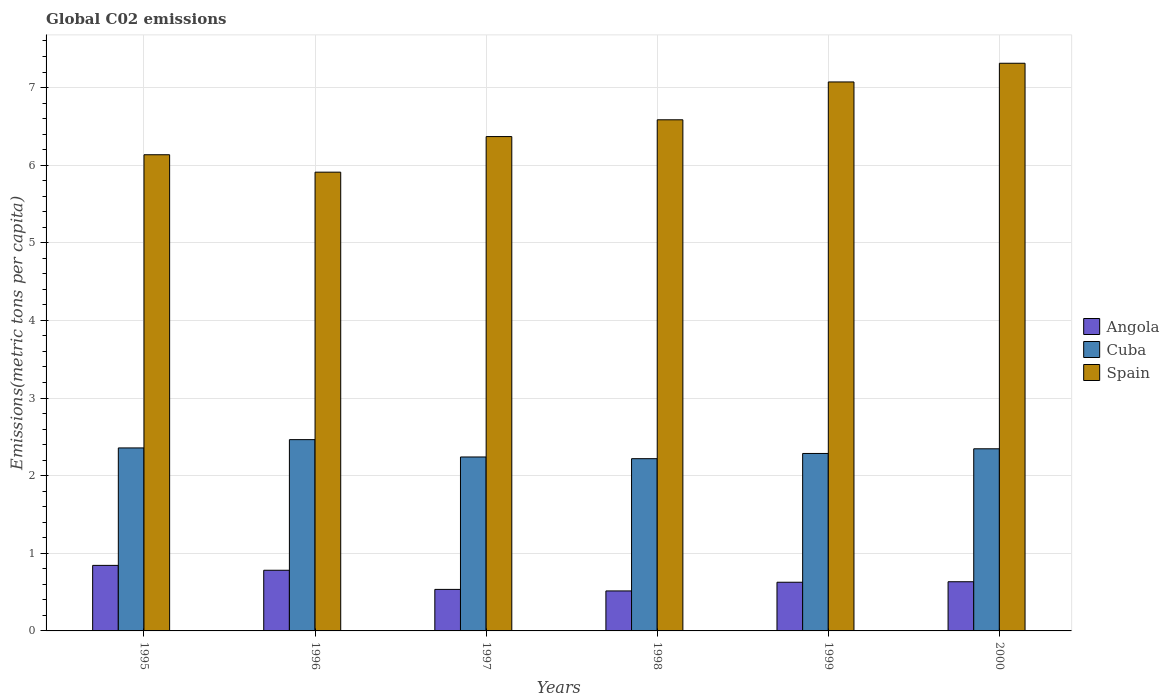How many different coloured bars are there?
Ensure brevity in your answer.  3. How many groups of bars are there?
Your response must be concise. 6. Are the number of bars per tick equal to the number of legend labels?
Your answer should be very brief. Yes. How many bars are there on the 4th tick from the left?
Ensure brevity in your answer.  3. How many bars are there on the 3rd tick from the right?
Provide a short and direct response. 3. What is the amount of CO2 emitted in in Spain in 1998?
Offer a very short reply. 6.58. Across all years, what is the maximum amount of CO2 emitted in in Angola?
Offer a terse response. 0.84. Across all years, what is the minimum amount of CO2 emitted in in Angola?
Your answer should be very brief. 0.52. In which year was the amount of CO2 emitted in in Cuba maximum?
Keep it short and to the point. 1996. In which year was the amount of CO2 emitted in in Angola minimum?
Make the answer very short. 1998. What is the total amount of CO2 emitted in in Cuba in the graph?
Ensure brevity in your answer.  13.91. What is the difference between the amount of CO2 emitted in in Spain in 1997 and that in 1998?
Make the answer very short. -0.22. What is the difference between the amount of CO2 emitted in in Cuba in 1996 and the amount of CO2 emitted in in Angola in 1999?
Keep it short and to the point. 1.84. What is the average amount of CO2 emitted in in Angola per year?
Ensure brevity in your answer.  0.66. In the year 1997, what is the difference between the amount of CO2 emitted in in Spain and amount of CO2 emitted in in Angola?
Offer a very short reply. 5.83. What is the ratio of the amount of CO2 emitted in in Spain in 1995 to that in 1996?
Your answer should be compact. 1.04. Is the amount of CO2 emitted in in Spain in 1997 less than that in 2000?
Provide a short and direct response. Yes. What is the difference between the highest and the second highest amount of CO2 emitted in in Angola?
Your answer should be very brief. 0.06. What is the difference between the highest and the lowest amount of CO2 emitted in in Spain?
Make the answer very short. 1.4. In how many years, is the amount of CO2 emitted in in Angola greater than the average amount of CO2 emitted in in Angola taken over all years?
Offer a terse response. 2. Is the sum of the amount of CO2 emitted in in Spain in 1995 and 1999 greater than the maximum amount of CO2 emitted in in Cuba across all years?
Give a very brief answer. Yes. What does the 1st bar from the right in 1998 represents?
Ensure brevity in your answer.  Spain. Is it the case that in every year, the sum of the amount of CO2 emitted in in Spain and amount of CO2 emitted in in Angola is greater than the amount of CO2 emitted in in Cuba?
Offer a terse response. Yes. Are all the bars in the graph horizontal?
Offer a terse response. No. What is the difference between two consecutive major ticks on the Y-axis?
Offer a terse response. 1. Are the values on the major ticks of Y-axis written in scientific E-notation?
Make the answer very short. No. Does the graph contain any zero values?
Your response must be concise. No. How many legend labels are there?
Keep it short and to the point. 3. What is the title of the graph?
Make the answer very short. Global C02 emissions. Does "Montenegro" appear as one of the legend labels in the graph?
Your answer should be very brief. No. What is the label or title of the X-axis?
Your answer should be compact. Years. What is the label or title of the Y-axis?
Offer a very short reply. Emissions(metric tons per capita). What is the Emissions(metric tons per capita) in Angola in 1995?
Ensure brevity in your answer.  0.84. What is the Emissions(metric tons per capita) of Cuba in 1995?
Give a very brief answer. 2.36. What is the Emissions(metric tons per capita) in Spain in 1995?
Make the answer very short. 6.13. What is the Emissions(metric tons per capita) of Angola in 1996?
Your answer should be compact. 0.78. What is the Emissions(metric tons per capita) of Cuba in 1996?
Give a very brief answer. 2.46. What is the Emissions(metric tons per capita) in Spain in 1996?
Keep it short and to the point. 5.91. What is the Emissions(metric tons per capita) of Angola in 1997?
Your response must be concise. 0.53. What is the Emissions(metric tons per capita) of Cuba in 1997?
Your response must be concise. 2.24. What is the Emissions(metric tons per capita) of Spain in 1997?
Offer a very short reply. 6.37. What is the Emissions(metric tons per capita) in Angola in 1998?
Provide a short and direct response. 0.52. What is the Emissions(metric tons per capita) in Cuba in 1998?
Your response must be concise. 2.22. What is the Emissions(metric tons per capita) in Spain in 1998?
Provide a short and direct response. 6.58. What is the Emissions(metric tons per capita) of Angola in 1999?
Keep it short and to the point. 0.63. What is the Emissions(metric tons per capita) in Cuba in 1999?
Your response must be concise. 2.29. What is the Emissions(metric tons per capita) in Spain in 1999?
Make the answer very short. 7.07. What is the Emissions(metric tons per capita) of Angola in 2000?
Your answer should be compact. 0.63. What is the Emissions(metric tons per capita) of Cuba in 2000?
Make the answer very short. 2.35. What is the Emissions(metric tons per capita) of Spain in 2000?
Make the answer very short. 7.31. Across all years, what is the maximum Emissions(metric tons per capita) of Angola?
Provide a succinct answer. 0.84. Across all years, what is the maximum Emissions(metric tons per capita) in Cuba?
Offer a very short reply. 2.46. Across all years, what is the maximum Emissions(metric tons per capita) in Spain?
Ensure brevity in your answer.  7.31. Across all years, what is the minimum Emissions(metric tons per capita) of Angola?
Give a very brief answer. 0.52. Across all years, what is the minimum Emissions(metric tons per capita) of Cuba?
Your answer should be compact. 2.22. Across all years, what is the minimum Emissions(metric tons per capita) in Spain?
Give a very brief answer. 5.91. What is the total Emissions(metric tons per capita) of Angola in the graph?
Your response must be concise. 3.94. What is the total Emissions(metric tons per capita) of Cuba in the graph?
Offer a very short reply. 13.91. What is the total Emissions(metric tons per capita) of Spain in the graph?
Ensure brevity in your answer.  39.38. What is the difference between the Emissions(metric tons per capita) in Angola in 1995 and that in 1996?
Provide a succinct answer. 0.06. What is the difference between the Emissions(metric tons per capita) of Cuba in 1995 and that in 1996?
Give a very brief answer. -0.11. What is the difference between the Emissions(metric tons per capita) of Spain in 1995 and that in 1996?
Provide a short and direct response. 0.22. What is the difference between the Emissions(metric tons per capita) of Angola in 1995 and that in 1997?
Make the answer very short. 0.31. What is the difference between the Emissions(metric tons per capita) of Cuba in 1995 and that in 1997?
Provide a short and direct response. 0.12. What is the difference between the Emissions(metric tons per capita) in Spain in 1995 and that in 1997?
Offer a very short reply. -0.23. What is the difference between the Emissions(metric tons per capita) of Angola in 1995 and that in 1998?
Ensure brevity in your answer.  0.33. What is the difference between the Emissions(metric tons per capita) of Cuba in 1995 and that in 1998?
Your answer should be very brief. 0.14. What is the difference between the Emissions(metric tons per capita) of Spain in 1995 and that in 1998?
Provide a succinct answer. -0.45. What is the difference between the Emissions(metric tons per capita) in Angola in 1995 and that in 1999?
Your answer should be compact. 0.22. What is the difference between the Emissions(metric tons per capita) in Cuba in 1995 and that in 1999?
Give a very brief answer. 0.07. What is the difference between the Emissions(metric tons per capita) of Spain in 1995 and that in 1999?
Keep it short and to the point. -0.94. What is the difference between the Emissions(metric tons per capita) in Angola in 1995 and that in 2000?
Provide a short and direct response. 0.21. What is the difference between the Emissions(metric tons per capita) in Cuba in 1995 and that in 2000?
Provide a short and direct response. 0.01. What is the difference between the Emissions(metric tons per capita) in Spain in 1995 and that in 2000?
Give a very brief answer. -1.18. What is the difference between the Emissions(metric tons per capita) in Angola in 1996 and that in 1997?
Your answer should be compact. 0.25. What is the difference between the Emissions(metric tons per capita) of Cuba in 1996 and that in 1997?
Your answer should be very brief. 0.22. What is the difference between the Emissions(metric tons per capita) of Spain in 1996 and that in 1997?
Offer a very short reply. -0.46. What is the difference between the Emissions(metric tons per capita) of Angola in 1996 and that in 1998?
Give a very brief answer. 0.27. What is the difference between the Emissions(metric tons per capita) in Cuba in 1996 and that in 1998?
Your response must be concise. 0.25. What is the difference between the Emissions(metric tons per capita) in Spain in 1996 and that in 1998?
Offer a terse response. -0.67. What is the difference between the Emissions(metric tons per capita) in Angola in 1996 and that in 1999?
Provide a short and direct response. 0.15. What is the difference between the Emissions(metric tons per capita) of Cuba in 1996 and that in 1999?
Provide a short and direct response. 0.18. What is the difference between the Emissions(metric tons per capita) of Spain in 1996 and that in 1999?
Keep it short and to the point. -1.16. What is the difference between the Emissions(metric tons per capita) of Angola in 1996 and that in 2000?
Keep it short and to the point. 0.15. What is the difference between the Emissions(metric tons per capita) of Cuba in 1996 and that in 2000?
Offer a very short reply. 0.12. What is the difference between the Emissions(metric tons per capita) in Spain in 1996 and that in 2000?
Ensure brevity in your answer.  -1.4. What is the difference between the Emissions(metric tons per capita) of Angola in 1997 and that in 1998?
Offer a terse response. 0.02. What is the difference between the Emissions(metric tons per capita) in Cuba in 1997 and that in 1998?
Ensure brevity in your answer.  0.02. What is the difference between the Emissions(metric tons per capita) in Spain in 1997 and that in 1998?
Make the answer very short. -0.22. What is the difference between the Emissions(metric tons per capita) in Angola in 1997 and that in 1999?
Provide a succinct answer. -0.09. What is the difference between the Emissions(metric tons per capita) in Cuba in 1997 and that in 1999?
Provide a short and direct response. -0.05. What is the difference between the Emissions(metric tons per capita) of Spain in 1997 and that in 1999?
Offer a terse response. -0.7. What is the difference between the Emissions(metric tons per capita) in Angola in 1997 and that in 2000?
Your answer should be compact. -0.1. What is the difference between the Emissions(metric tons per capita) of Cuba in 1997 and that in 2000?
Your response must be concise. -0.11. What is the difference between the Emissions(metric tons per capita) of Spain in 1997 and that in 2000?
Make the answer very short. -0.94. What is the difference between the Emissions(metric tons per capita) in Angola in 1998 and that in 1999?
Provide a succinct answer. -0.11. What is the difference between the Emissions(metric tons per capita) in Cuba in 1998 and that in 1999?
Offer a terse response. -0.07. What is the difference between the Emissions(metric tons per capita) of Spain in 1998 and that in 1999?
Offer a very short reply. -0.49. What is the difference between the Emissions(metric tons per capita) of Angola in 1998 and that in 2000?
Offer a terse response. -0.12. What is the difference between the Emissions(metric tons per capita) in Cuba in 1998 and that in 2000?
Your response must be concise. -0.13. What is the difference between the Emissions(metric tons per capita) in Spain in 1998 and that in 2000?
Your answer should be very brief. -0.73. What is the difference between the Emissions(metric tons per capita) in Angola in 1999 and that in 2000?
Your answer should be compact. -0.01. What is the difference between the Emissions(metric tons per capita) in Cuba in 1999 and that in 2000?
Make the answer very short. -0.06. What is the difference between the Emissions(metric tons per capita) of Spain in 1999 and that in 2000?
Make the answer very short. -0.24. What is the difference between the Emissions(metric tons per capita) in Angola in 1995 and the Emissions(metric tons per capita) in Cuba in 1996?
Give a very brief answer. -1.62. What is the difference between the Emissions(metric tons per capita) of Angola in 1995 and the Emissions(metric tons per capita) of Spain in 1996?
Keep it short and to the point. -5.07. What is the difference between the Emissions(metric tons per capita) of Cuba in 1995 and the Emissions(metric tons per capita) of Spain in 1996?
Ensure brevity in your answer.  -3.55. What is the difference between the Emissions(metric tons per capita) in Angola in 1995 and the Emissions(metric tons per capita) in Cuba in 1997?
Offer a terse response. -1.4. What is the difference between the Emissions(metric tons per capita) in Angola in 1995 and the Emissions(metric tons per capita) in Spain in 1997?
Make the answer very short. -5.52. What is the difference between the Emissions(metric tons per capita) in Cuba in 1995 and the Emissions(metric tons per capita) in Spain in 1997?
Keep it short and to the point. -4.01. What is the difference between the Emissions(metric tons per capita) of Angola in 1995 and the Emissions(metric tons per capita) of Cuba in 1998?
Provide a succinct answer. -1.37. What is the difference between the Emissions(metric tons per capita) of Angola in 1995 and the Emissions(metric tons per capita) of Spain in 1998?
Give a very brief answer. -5.74. What is the difference between the Emissions(metric tons per capita) in Cuba in 1995 and the Emissions(metric tons per capita) in Spain in 1998?
Ensure brevity in your answer.  -4.23. What is the difference between the Emissions(metric tons per capita) in Angola in 1995 and the Emissions(metric tons per capita) in Cuba in 1999?
Offer a very short reply. -1.44. What is the difference between the Emissions(metric tons per capita) in Angola in 1995 and the Emissions(metric tons per capita) in Spain in 1999?
Keep it short and to the point. -6.23. What is the difference between the Emissions(metric tons per capita) in Cuba in 1995 and the Emissions(metric tons per capita) in Spain in 1999?
Ensure brevity in your answer.  -4.71. What is the difference between the Emissions(metric tons per capita) of Angola in 1995 and the Emissions(metric tons per capita) of Cuba in 2000?
Provide a short and direct response. -1.5. What is the difference between the Emissions(metric tons per capita) in Angola in 1995 and the Emissions(metric tons per capita) in Spain in 2000?
Ensure brevity in your answer.  -6.47. What is the difference between the Emissions(metric tons per capita) in Cuba in 1995 and the Emissions(metric tons per capita) in Spain in 2000?
Offer a terse response. -4.96. What is the difference between the Emissions(metric tons per capita) in Angola in 1996 and the Emissions(metric tons per capita) in Cuba in 1997?
Ensure brevity in your answer.  -1.46. What is the difference between the Emissions(metric tons per capita) of Angola in 1996 and the Emissions(metric tons per capita) of Spain in 1997?
Your response must be concise. -5.59. What is the difference between the Emissions(metric tons per capita) in Cuba in 1996 and the Emissions(metric tons per capita) in Spain in 1997?
Ensure brevity in your answer.  -3.9. What is the difference between the Emissions(metric tons per capita) in Angola in 1996 and the Emissions(metric tons per capita) in Cuba in 1998?
Offer a terse response. -1.44. What is the difference between the Emissions(metric tons per capita) of Angola in 1996 and the Emissions(metric tons per capita) of Spain in 1998?
Your answer should be compact. -5.8. What is the difference between the Emissions(metric tons per capita) in Cuba in 1996 and the Emissions(metric tons per capita) in Spain in 1998?
Your answer should be very brief. -4.12. What is the difference between the Emissions(metric tons per capita) in Angola in 1996 and the Emissions(metric tons per capita) in Cuba in 1999?
Your response must be concise. -1.5. What is the difference between the Emissions(metric tons per capita) in Angola in 1996 and the Emissions(metric tons per capita) in Spain in 1999?
Your answer should be compact. -6.29. What is the difference between the Emissions(metric tons per capita) in Cuba in 1996 and the Emissions(metric tons per capita) in Spain in 1999?
Your answer should be compact. -4.61. What is the difference between the Emissions(metric tons per capita) in Angola in 1996 and the Emissions(metric tons per capita) in Cuba in 2000?
Make the answer very short. -1.56. What is the difference between the Emissions(metric tons per capita) in Angola in 1996 and the Emissions(metric tons per capita) in Spain in 2000?
Offer a terse response. -6.53. What is the difference between the Emissions(metric tons per capita) of Cuba in 1996 and the Emissions(metric tons per capita) of Spain in 2000?
Give a very brief answer. -4.85. What is the difference between the Emissions(metric tons per capita) in Angola in 1997 and the Emissions(metric tons per capita) in Cuba in 1998?
Make the answer very short. -1.68. What is the difference between the Emissions(metric tons per capita) in Angola in 1997 and the Emissions(metric tons per capita) in Spain in 1998?
Ensure brevity in your answer.  -6.05. What is the difference between the Emissions(metric tons per capita) of Cuba in 1997 and the Emissions(metric tons per capita) of Spain in 1998?
Offer a very short reply. -4.34. What is the difference between the Emissions(metric tons per capita) of Angola in 1997 and the Emissions(metric tons per capita) of Cuba in 1999?
Your response must be concise. -1.75. What is the difference between the Emissions(metric tons per capita) in Angola in 1997 and the Emissions(metric tons per capita) in Spain in 1999?
Your response must be concise. -6.54. What is the difference between the Emissions(metric tons per capita) of Cuba in 1997 and the Emissions(metric tons per capita) of Spain in 1999?
Make the answer very short. -4.83. What is the difference between the Emissions(metric tons per capita) in Angola in 1997 and the Emissions(metric tons per capita) in Cuba in 2000?
Ensure brevity in your answer.  -1.81. What is the difference between the Emissions(metric tons per capita) of Angola in 1997 and the Emissions(metric tons per capita) of Spain in 2000?
Keep it short and to the point. -6.78. What is the difference between the Emissions(metric tons per capita) of Cuba in 1997 and the Emissions(metric tons per capita) of Spain in 2000?
Keep it short and to the point. -5.07. What is the difference between the Emissions(metric tons per capita) of Angola in 1998 and the Emissions(metric tons per capita) of Cuba in 1999?
Keep it short and to the point. -1.77. What is the difference between the Emissions(metric tons per capita) of Angola in 1998 and the Emissions(metric tons per capita) of Spain in 1999?
Your response must be concise. -6.56. What is the difference between the Emissions(metric tons per capita) of Cuba in 1998 and the Emissions(metric tons per capita) of Spain in 1999?
Your answer should be compact. -4.85. What is the difference between the Emissions(metric tons per capita) of Angola in 1998 and the Emissions(metric tons per capita) of Cuba in 2000?
Make the answer very short. -1.83. What is the difference between the Emissions(metric tons per capita) of Angola in 1998 and the Emissions(metric tons per capita) of Spain in 2000?
Keep it short and to the point. -6.8. What is the difference between the Emissions(metric tons per capita) in Cuba in 1998 and the Emissions(metric tons per capita) in Spain in 2000?
Your response must be concise. -5.09. What is the difference between the Emissions(metric tons per capita) in Angola in 1999 and the Emissions(metric tons per capita) in Cuba in 2000?
Give a very brief answer. -1.72. What is the difference between the Emissions(metric tons per capita) in Angola in 1999 and the Emissions(metric tons per capita) in Spain in 2000?
Your answer should be very brief. -6.69. What is the difference between the Emissions(metric tons per capita) of Cuba in 1999 and the Emissions(metric tons per capita) of Spain in 2000?
Provide a succinct answer. -5.03. What is the average Emissions(metric tons per capita) of Angola per year?
Provide a succinct answer. 0.66. What is the average Emissions(metric tons per capita) in Cuba per year?
Your answer should be very brief. 2.32. What is the average Emissions(metric tons per capita) of Spain per year?
Make the answer very short. 6.56. In the year 1995, what is the difference between the Emissions(metric tons per capita) in Angola and Emissions(metric tons per capita) in Cuba?
Offer a very short reply. -1.51. In the year 1995, what is the difference between the Emissions(metric tons per capita) in Angola and Emissions(metric tons per capita) in Spain?
Give a very brief answer. -5.29. In the year 1995, what is the difference between the Emissions(metric tons per capita) of Cuba and Emissions(metric tons per capita) of Spain?
Your answer should be compact. -3.78. In the year 1996, what is the difference between the Emissions(metric tons per capita) of Angola and Emissions(metric tons per capita) of Cuba?
Provide a succinct answer. -1.68. In the year 1996, what is the difference between the Emissions(metric tons per capita) in Angola and Emissions(metric tons per capita) in Spain?
Your answer should be compact. -5.13. In the year 1996, what is the difference between the Emissions(metric tons per capita) in Cuba and Emissions(metric tons per capita) in Spain?
Keep it short and to the point. -3.45. In the year 1997, what is the difference between the Emissions(metric tons per capita) of Angola and Emissions(metric tons per capita) of Cuba?
Your answer should be very brief. -1.71. In the year 1997, what is the difference between the Emissions(metric tons per capita) of Angola and Emissions(metric tons per capita) of Spain?
Offer a very short reply. -5.83. In the year 1997, what is the difference between the Emissions(metric tons per capita) of Cuba and Emissions(metric tons per capita) of Spain?
Keep it short and to the point. -4.13. In the year 1998, what is the difference between the Emissions(metric tons per capita) of Angola and Emissions(metric tons per capita) of Cuba?
Your response must be concise. -1.7. In the year 1998, what is the difference between the Emissions(metric tons per capita) in Angola and Emissions(metric tons per capita) in Spain?
Your response must be concise. -6.07. In the year 1998, what is the difference between the Emissions(metric tons per capita) in Cuba and Emissions(metric tons per capita) in Spain?
Offer a terse response. -4.37. In the year 1999, what is the difference between the Emissions(metric tons per capita) in Angola and Emissions(metric tons per capita) in Cuba?
Ensure brevity in your answer.  -1.66. In the year 1999, what is the difference between the Emissions(metric tons per capita) in Angola and Emissions(metric tons per capita) in Spain?
Provide a succinct answer. -6.44. In the year 1999, what is the difference between the Emissions(metric tons per capita) of Cuba and Emissions(metric tons per capita) of Spain?
Offer a terse response. -4.79. In the year 2000, what is the difference between the Emissions(metric tons per capita) of Angola and Emissions(metric tons per capita) of Cuba?
Offer a very short reply. -1.71. In the year 2000, what is the difference between the Emissions(metric tons per capita) of Angola and Emissions(metric tons per capita) of Spain?
Your response must be concise. -6.68. In the year 2000, what is the difference between the Emissions(metric tons per capita) in Cuba and Emissions(metric tons per capita) in Spain?
Your response must be concise. -4.97. What is the ratio of the Emissions(metric tons per capita) in Angola in 1995 to that in 1996?
Your answer should be very brief. 1.08. What is the ratio of the Emissions(metric tons per capita) of Cuba in 1995 to that in 1996?
Your answer should be very brief. 0.96. What is the ratio of the Emissions(metric tons per capita) in Spain in 1995 to that in 1996?
Ensure brevity in your answer.  1.04. What is the ratio of the Emissions(metric tons per capita) in Angola in 1995 to that in 1997?
Offer a very short reply. 1.58. What is the ratio of the Emissions(metric tons per capita) of Cuba in 1995 to that in 1997?
Keep it short and to the point. 1.05. What is the ratio of the Emissions(metric tons per capita) of Spain in 1995 to that in 1997?
Keep it short and to the point. 0.96. What is the ratio of the Emissions(metric tons per capita) of Angola in 1995 to that in 1998?
Provide a short and direct response. 1.64. What is the ratio of the Emissions(metric tons per capita) of Spain in 1995 to that in 1998?
Make the answer very short. 0.93. What is the ratio of the Emissions(metric tons per capita) in Angola in 1995 to that in 1999?
Provide a succinct answer. 1.35. What is the ratio of the Emissions(metric tons per capita) of Cuba in 1995 to that in 1999?
Your response must be concise. 1.03. What is the ratio of the Emissions(metric tons per capita) of Spain in 1995 to that in 1999?
Your response must be concise. 0.87. What is the ratio of the Emissions(metric tons per capita) of Angola in 1995 to that in 2000?
Offer a very short reply. 1.33. What is the ratio of the Emissions(metric tons per capita) in Spain in 1995 to that in 2000?
Make the answer very short. 0.84. What is the ratio of the Emissions(metric tons per capita) in Angola in 1996 to that in 1997?
Your answer should be compact. 1.46. What is the ratio of the Emissions(metric tons per capita) in Cuba in 1996 to that in 1997?
Your answer should be compact. 1.1. What is the ratio of the Emissions(metric tons per capita) in Spain in 1996 to that in 1997?
Provide a succinct answer. 0.93. What is the ratio of the Emissions(metric tons per capita) of Angola in 1996 to that in 1998?
Keep it short and to the point. 1.52. What is the ratio of the Emissions(metric tons per capita) in Cuba in 1996 to that in 1998?
Your answer should be very brief. 1.11. What is the ratio of the Emissions(metric tons per capita) of Spain in 1996 to that in 1998?
Give a very brief answer. 0.9. What is the ratio of the Emissions(metric tons per capita) of Angola in 1996 to that in 1999?
Your answer should be compact. 1.25. What is the ratio of the Emissions(metric tons per capita) of Cuba in 1996 to that in 1999?
Give a very brief answer. 1.08. What is the ratio of the Emissions(metric tons per capita) of Spain in 1996 to that in 1999?
Make the answer very short. 0.84. What is the ratio of the Emissions(metric tons per capita) in Angola in 1996 to that in 2000?
Offer a very short reply. 1.23. What is the ratio of the Emissions(metric tons per capita) of Cuba in 1996 to that in 2000?
Keep it short and to the point. 1.05. What is the ratio of the Emissions(metric tons per capita) of Spain in 1996 to that in 2000?
Give a very brief answer. 0.81. What is the ratio of the Emissions(metric tons per capita) in Angola in 1997 to that in 1998?
Offer a terse response. 1.04. What is the ratio of the Emissions(metric tons per capita) in Cuba in 1997 to that in 1998?
Your answer should be very brief. 1.01. What is the ratio of the Emissions(metric tons per capita) of Spain in 1997 to that in 1998?
Offer a terse response. 0.97. What is the ratio of the Emissions(metric tons per capita) in Angola in 1997 to that in 1999?
Make the answer very short. 0.85. What is the ratio of the Emissions(metric tons per capita) in Cuba in 1997 to that in 1999?
Give a very brief answer. 0.98. What is the ratio of the Emissions(metric tons per capita) of Spain in 1997 to that in 1999?
Provide a short and direct response. 0.9. What is the ratio of the Emissions(metric tons per capita) of Angola in 1997 to that in 2000?
Provide a succinct answer. 0.84. What is the ratio of the Emissions(metric tons per capita) in Cuba in 1997 to that in 2000?
Keep it short and to the point. 0.95. What is the ratio of the Emissions(metric tons per capita) in Spain in 1997 to that in 2000?
Offer a very short reply. 0.87. What is the ratio of the Emissions(metric tons per capita) of Angola in 1998 to that in 1999?
Your answer should be compact. 0.82. What is the ratio of the Emissions(metric tons per capita) of Cuba in 1998 to that in 1999?
Provide a succinct answer. 0.97. What is the ratio of the Emissions(metric tons per capita) of Spain in 1998 to that in 1999?
Your response must be concise. 0.93. What is the ratio of the Emissions(metric tons per capita) in Angola in 1998 to that in 2000?
Your answer should be compact. 0.81. What is the ratio of the Emissions(metric tons per capita) in Cuba in 1998 to that in 2000?
Offer a terse response. 0.95. What is the ratio of the Emissions(metric tons per capita) of Spain in 1998 to that in 2000?
Make the answer very short. 0.9. What is the ratio of the Emissions(metric tons per capita) in Cuba in 1999 to that in 2000?
Your answer should be compact. 0.97. What is the ratio of the Emissions(metric tons per capita) in Spain in 1999 to that in 2000?
Give a very brief answer. 0.97. What is the difference between the highest and the second highest Emissions(metric tons per capita) in Angola?
Your response must be concise. 0.06. What is the difference between the highest and the second highest Emissions(metric tons per capita) in Cuba?
Provide a short and direct response. 0.11. What is the difference between the highest and the second highest Emissions(metric tons per capita) of Spain?
Your response must be concise. 0.24. What is the difference between the highest and the lowest Emissions(metric tons per capita) in Angola?
Offer a terse response. 0.33. What is the difference between the highest and the lowest Emissions(metric tons per capita) of Cuba?
Provide a short and direct response. 0.25. What is the difference between the highest and the lowest Emissions(metric tons per capita) in Spain?
Ensure brevity in your answer.  1.4. 